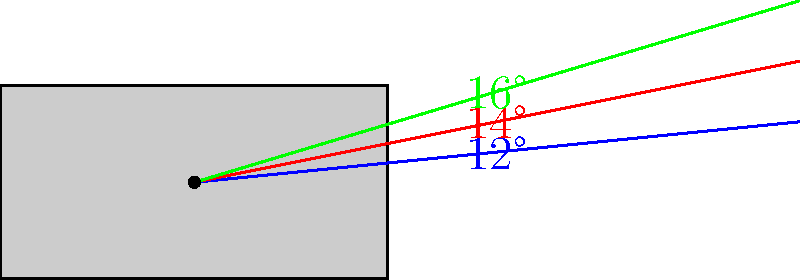In the diagram, three different jazz guitar models are represented by the colored lines showing the angle between the guitar neck and body. The blue, red, and green lines correspond to angles of 12°, 14°, and 16° respectively. If you were to combine these three models to create a new "fusion" guitar with an average neck angle, what would be the resulting angle between the neck and body? To find the average angle for the "fusion" guitar, we need to follow these steps:

1. Identify the given angles:
   - Blue line: 12°
   - Red line: 14°
   - Green line: 16°

2. Calculate the sum of all angles:
   $12° + 14° + 16° = 42°$

3. Count the total number of angles:
   There are 3 angles in total.

4. Calculate the average by dividing the sum by the total number:
   $\text{Average} = \frac{\text{Sum of angles}}{\text{Number of angles}} = \frac{42°}{3} = 14°$

Therefore, the resulting angle between the neck and body of the "fusion" guitar would be 14°.
Answer: 14° 